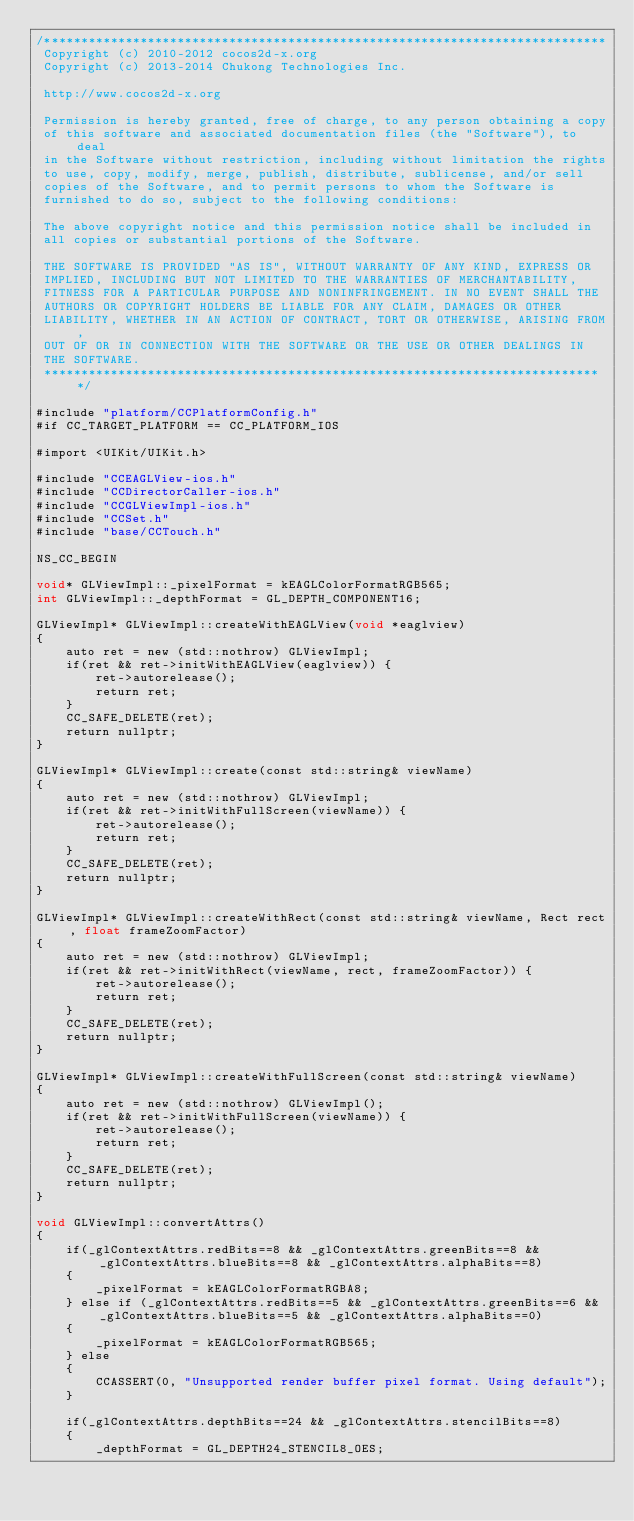Convert code to text. <code><loc_0><loc_0><loc_500><loc_500><_ObjectiveC_>/****************************************************************************
 Copyright (c) 2010-2012 cocos2d-x.org
 Copyright (c) 2013-2014 Chukong Technologies Inc.

 http://www.cocos2d-x.org

 Permission is hereby granted, free of charge, to any person obtaining a copy
 of this software and associated documentation files (the "Software"), to deal
 in the Software without restriction, including without limitation the rights
 to use, copy, modify, merge, publish, distribute, sublicense, and/or sell
 copies of the Software, and to permit persons to whom the Software is
 furnished to do so, subject to the following conditions:

 The above copyright notice and this permission notice shall be included in
 all copies or substantial portions of the Software.

 THE SOFTWARE IS PROVIDED "AS IS", WITHOUT WARRANTY OF ANY KIND, EXPRESS OR
 IMPLIED, INCLUDING BUT NOT LIMITED TO THE WARRANTIES OF MERCHANTABILITY,
 FITNESS FOR A PARTICULAR PURPOSE AND NONINFRINGEMENT. IN NO EVENT SHALL THE
 AUTHORS OR COPYRIGHT HOLDERS BE LIABLE FOR ANY CLAIM, DAMAGES OR OTHER
 LIABILITY, WHETHER IN AN ACTION OF CONTRACT, TORT OR OTHERWISE, ARISING FROM,
 OUT OF OR IN CONNECTION WITH THE SOFTWARE OR THE USE OR OTHER DEALINGS IN
 THE SOFTWARE.
 ****************************************************************************/

#include "platform/CCPlatformConfig.h"
#if CC_TARGET_PLATFORM == CC_PLATFORM_IOS

#import <UIKit/UIKit.h>

#include "CCEAGLView-ios.h"
#include "CCDirectorCaller-ios.h"
#include "CCGLViewImpl-ios.h"
#include "CCSet.h"
#include "base/CCTouch.h"

NS_CC_BEGIN

void* GLViewImpl::_pixelFormat = kEAGLColorFormatRGB565;
int GLViewImpl::_depthFormat = GL_DEPTH_COMPONENT16;

GLViewImpl* GLViewImpl::createWithEAGLView(void *eaglview)
{
    auto ret = new (std::nothrow) GLViewImpl;
    if(ret && ret->initWithEAGLView(eaglview)) {
        ret->autorelease();
        return ret;
    }
    CC_SAFE_DELETE(ret);
    return nullptr;
}

GLViewImpl* GLViewImpl::create(const std::string& viewName)
{
    auto ret = new (std::nothrow) GLViewImpl;
    if(ret && ret->initWithFullScreen(viewName)) {
        ret->autorelease();
        return ret;
    }
    CC_SAFE_DELETE(ret);
    return nullptr;
}

GLViewImpl* GLViewImpl::createWithRect(const std::string& viewName, Rect rect, float frameZoomFactor)
{
    auto ret = new (std::nothrow) GLViewImpl;
    if(ret && ret->initWithRect(viewName, rect, frameZoomFactor)) {
        ret->autorelease();
        return ret;
    }
    CC_SAFE_DELETE(ret);
    return nullptr;
}

GLViewImpl* GLViewImpl::createWithFullScreen(const std::string& viewName)
{
    auto ret = new (std::nothrow) GLViewImpl();
    if(ret && ret->initWithFullScreen(viewName)) {
        ret->autorelease();
        return ret;
    }
    CC_SAFE_DELETE(ret);
    return nullptr;
}

void GLViewImpl::convertAttrs()
{
    if(_glContextAttrs.redBits==8 && _glContextAttrs.greenBits==8 && _glContextAttrs.blueBits==8 && _glContextAttrs.alphaBits==8)
    {
        _pixelFormat = kEAGLColorFormatRGBA8;
    } else if (_glContextAttrs.redBits==5 && _glContextAttrs.greenBits==6 && _glContextAttrs.blueBits==5 && _glContextAttrs.alphaBits==0)
    {
        _pixelFormat = kEAGLColorFormatRGB565;
    } else
    {
        CCASSERT(0, "Unsupported render buffer pixel format. Using default");
    }

    if(_glContextAttrs.depthBits==24 && _glContextAttrs.stencilBits==8)
    {
        _depthFormat = GL_DEPTH24_STENCIL8_OES;</code> 